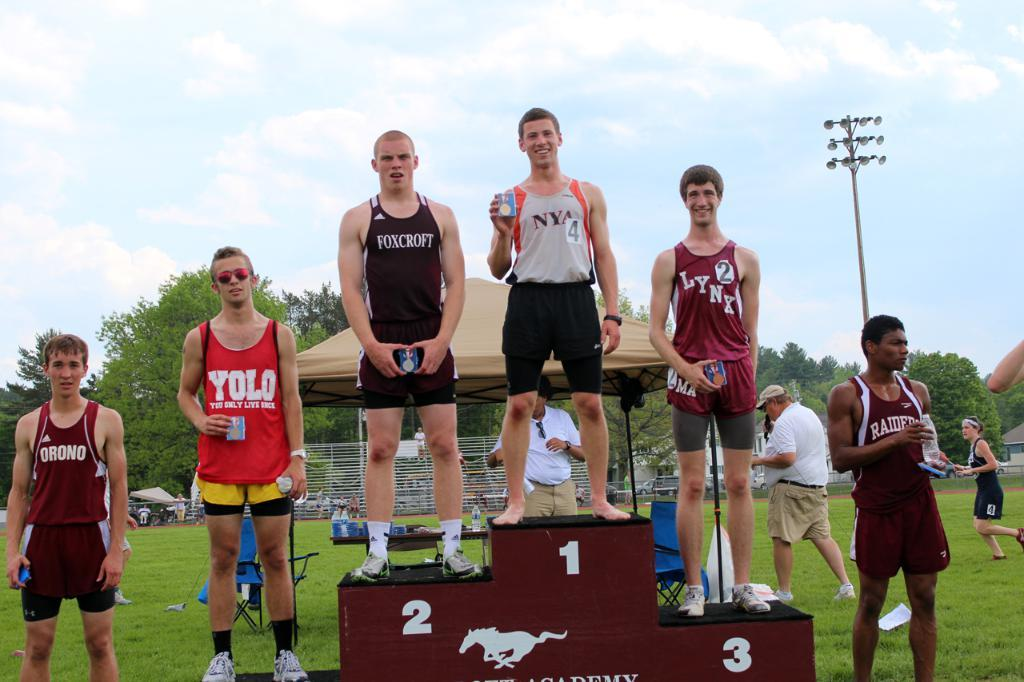<image>
Describe the image concisely. The winners of a track and field event are on the podium, the second place person wears a shirt from foxcroft. 